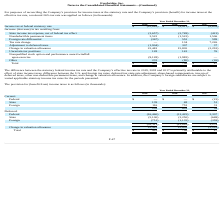According to Everbridge's financial document, What was the notional tax rate? According to the financial document, 26%. The relevant text states: "income taxes at the effective tax rate, a notional 26% tax rate was applied as follows (in thousands):..." Also, What was the Income tax at federal statutory rate in 2019, 2018 and 2017? The document contains multiple relevant values: $(10,883), $(9,811), $(6,659) (in thousands). From the document: "Income tax at federal statutory rate $ (10,883) $ (9,811) $ (6,659) x at federal statutory rate $ (10,883) $ (9,811) $ (6,659) Income tax at federal s..." Also, What was the reason for difference between he statutory federal income tax rate and the Company’s effective tax rate in 2019, 2018 and 2017? the effect of state income taxes, difference between the U.S. and foreign tax rates, deferred tax state rate adjustment, share-based compensation, true up of deferred taxes, other non-deductible permanent items, and change in valuation allowance.. The document states: "n 2019, 2018 and 2017 is primarily attributable to the effect of state income taxes, difference between the U.S. and foreign tax rates, deferred tax s..." Additionally, In which year was State income tax expense, net of federal tax effect less than (1,000) thousands? According to the financial document, 2017. The relevant text states: "2019 2018 2017..." Also, can you calculate: What is the average Nondeductible permanent items from 2017-2019? To answer this question, I need to perform calculations using the financial data. The calculation is: (3,522 - 1,522 + 1,506) / 3, which equals 1168.67 (in thousands). This is based on the information: "Nondeductible permanent items 3,522 (1,522) 1,506 Nondeductible permanent items 3,522 (1,522) 1,506 Nondeductible permanent items 3,522 (1,522) 1,506..." The key data points involved are: 1,506, 1,522, 3,522. Also, can you calculate: What was the average Tax rate change from 2017-2019? To answer this question, I need to perform calculations using the financial data. The calculation is: (0 + 134 + 7,226) / 3, which equals 2453.33 (in thousands). This is based on the information: "Tax rate change — 134 7,226 2019 2018 2017 Tax rate change — 134 7,226..." The key data points involved are: 0, 134, 7,226. 